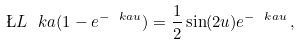<formula> <loc_0><loc_0><loc_500><loc_500>\L L _ { \ } k a ( 1 - e ^ { - \ k a u } ) = \frac { 1 } { 2 } \sin ( 2 u ) e ^ { - \ k a u } \, ,</formula> 